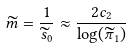<formula> <loc_0><loc_0><loc_500><loc_500>\widetilde { m } = \frac { 1 } { \widetilde { s } _ { 0 } } \approx \frac { 2 c _ { 2 } } { \log ( \widetilde { \pi } _ { 1 } ) }</formula> 